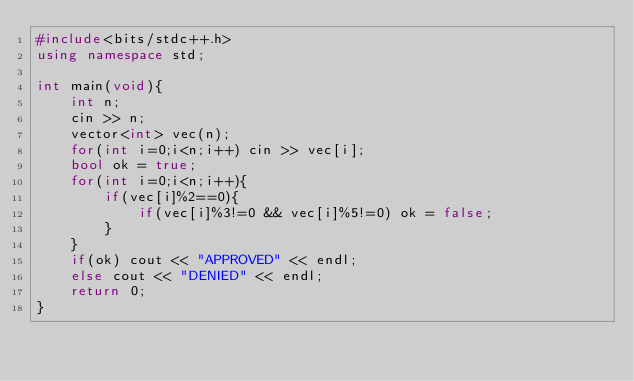<code> <loc_0><loc_0><loc_500><loc_500><_C++_>#include<bits/stdc++.h>
using namespace std;

int main(void){
    int n;
    cin >> n;
    vector<int> vec(n);
    for(int i=0;i<n;i++) cin >> vec[i];
    bool ok = true;
    for(int i=0;i<n;i++){
        if(vec[i]%2==0){
            if(vec[i]%3!=0 && vec[i]%5!=0) ok = false;
        }
    }
    if(ok) cout << "APPROVED" << endl;
    else cout << "DENIED" << endl;
    return 0;
}</code> 